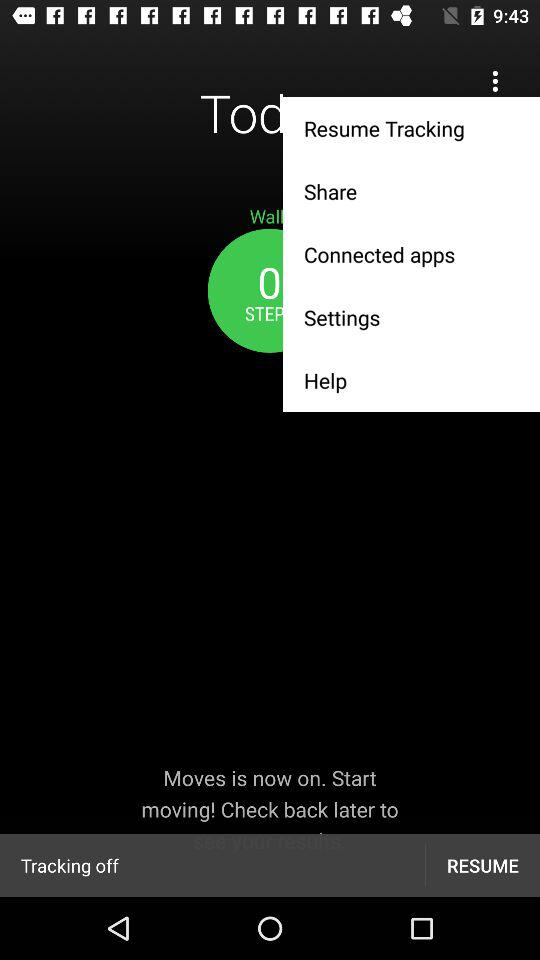How many steps have I taken so far?
Answer the question using a single word or phrase. 0 